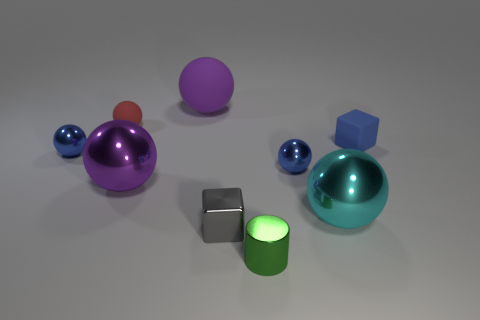Subtract all small matte balls. How many balls are left? 5 Subtract all red spheres. How many spheres are left? 5 Subtract all gray spheres. Subtract all cyan cylinders. How many spheres are left? 6 Add 1 small yellow objects. How many objects exist? 10 Subtract all cylinders. How many objects are left? 8 Subtract all tiny gray rubber blocks. Subtract all rubber cubes. How many objects are left? 8 Add 7 cyan metal spheres. How many cyan metal spheres are left? 8 Add 1 tiny gray things. How many tiny gray things exist? 2 Subtract 0 brown cubes. How many objects are left? 9 